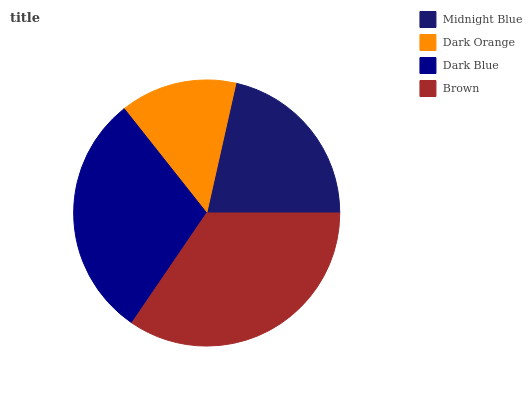Is Dark Orange the minimum?
Answer yes or no. Yes. Is Brown the maximum?
Answer yes or no. Yes. Is Dark Blue the minimum?
Answer yes or no. No. Is Dark Blue the maximum?
Answer yes or no. No. Is Dark Blue greater than Dark Orange?
Answer yes or no. Yes. Is Dark Orange less than Dark Blue?
Answer yes or no. Yes. Is Dark Orange greater than Dark Blue?
Answer yes or no. No. Is Dark Blue less than Dark Orange?
Answer yes or no. No. Is Dark Blue the high median?
Answer yes or no. Yes. Is Midnight Blue the low median?
Answer yes or no. Yes. Is Dark Orange the high median?
Answer yes or no. No. Is Dark Orange the low median?
Answer yes or no. No. 